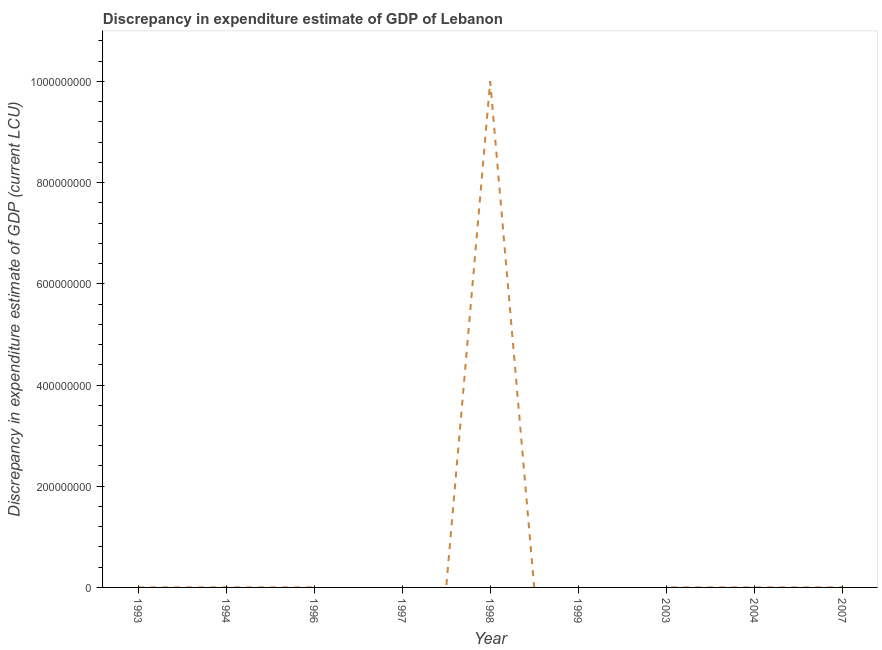What is the discrepancy in expenditure estimate of gdp in 1993?
Provide a succinct answer. 0. Across all years, what is the maximum discrepancy in expenditure estimate of gdp?
Ensure brevity in your answer.  1.00e+09. Across all years, what is the minimum discrepancy in expenditure estimate of gdp?
Ensure brevity in your answer.  0. In which year was the discrepancy in expenditure estimate of gdp maximum?
Your answer should be very brief. 1998. What is the sum of the discrepancy in expenditure estimate of gdp?
Your answer should be compact. 1.00e+09. What is the difference between the discrepancy in expenditure estimate of gdp in 1993 and 2003?
Keep it short and to the point. 0. What is the average discrepancy in expenditure estimate of gdp per year?
Make the answer very short. 1.11e+08. What is the median discrepancy in expenditure estimate of gdp?
Your response must be concise. 0. What is the ratio of the discrepancy in expenditure estimate of gdp in 1993 to that in 1994?
Give a very brief answer. 1. Is the difference between the discrepancy in expenditure estimate of gdp in 1998 and 2003 greater than the difference between any two years?
Keep it short and to the point. No. What is the difference between the highest and the second highest discrepancy in expenditure estimate of gdp?
Give a very brief answer. 1.00e+09. Is the sum of the discrepancy in expenditure estimate of gdp in 1993 and 1994 greater than the maximum discrepancy in expenditure estimate of gdp across all years?
Give a very brief answer. No. What is the difference between the highest and the lowest discrepancy in expenditure estimate of gdp?
Ensure brevity in your answer.  1.00e+09. How many years are there in the graph?
Offer a terse response. 9. What is the difference between two consecutive major ticks on the Y-axis?
Give a very brief answer. 2.00e+08. Are the values on the major ticks of Y-axis written in scientific E-notation?
Your answer should be very brief. No. What is the title of the graph?
Keep it short and to the point. Discrepancy in expenditure estimate of GDP of Lebanon. What is the label or title of the Y-axis?
Make the answer very short. Discrepancy in expenditure estimate of GDP (current LCU). What is the Discrepancy in expenditure estimate of GDP (current LCU) in 1993?
Provide a succinct answer. 0. What is the Discrepancy in expenditure estimate of GDP (current LCU) of 1994?
Provide a succinct answer. 0. What is the Discrepancy in expenditure estimate of GDP (current LCU) in 1996?
Your answer should be compact. 0. What is the Discrepancy in expenditure estimate of GDP (current LCU) of 1998?
Your answer should be very brief. 1.00e+09. What is the Discrepancy in expenditure estimate of GDP (current LCU) of 1999?
Offer a terse response. 0. What is the Discrepancy in expenditure estimate of GDP (current LCU) of 2007?
Give a very brief answer. 0. What is the difference between the Discrepancy in expenditure estimate of GDP (current LCU) in 1993 and 1994?
Your answer should be compact. 0. What is the difference between the Discrepancy in expenditure estimate of GDP (current LCU) in 1993 and 1998?
Give a very brief answer. -1.00e+09. What is the difference between the Discrepancy in expenditure estimate of GDP (current LCU) in 1994 and 1998?
Your answer should be compact. -1.00e+09. What is the difference between the Discrepancy in expenditure estimate of GDP (current LCU) in 1998 and 2003?
Your answer should be very brief. 1.00e+09. What is the ratio of the Discrepancy in expenditure estimate of GDP (current LCU) in 1993 to that in 2003?
Your response must be concise. 2. What is the ratio of the Discrepancy in expenditure estimate of GDP (current LCU) in 1994 to that in 1998?
Your response must be concise. 0. What is the ratio of the Discrepancy in expenditure estimate of GDP (current LCU) in 1994 to that in 2003?
Provide a succinct answer. 2. What is the ratio of the Discrepancy in expenditure estimate of GDP (current LCU) in 1998 to that in 2003?
Make the answer very short. 1.00e+12. 